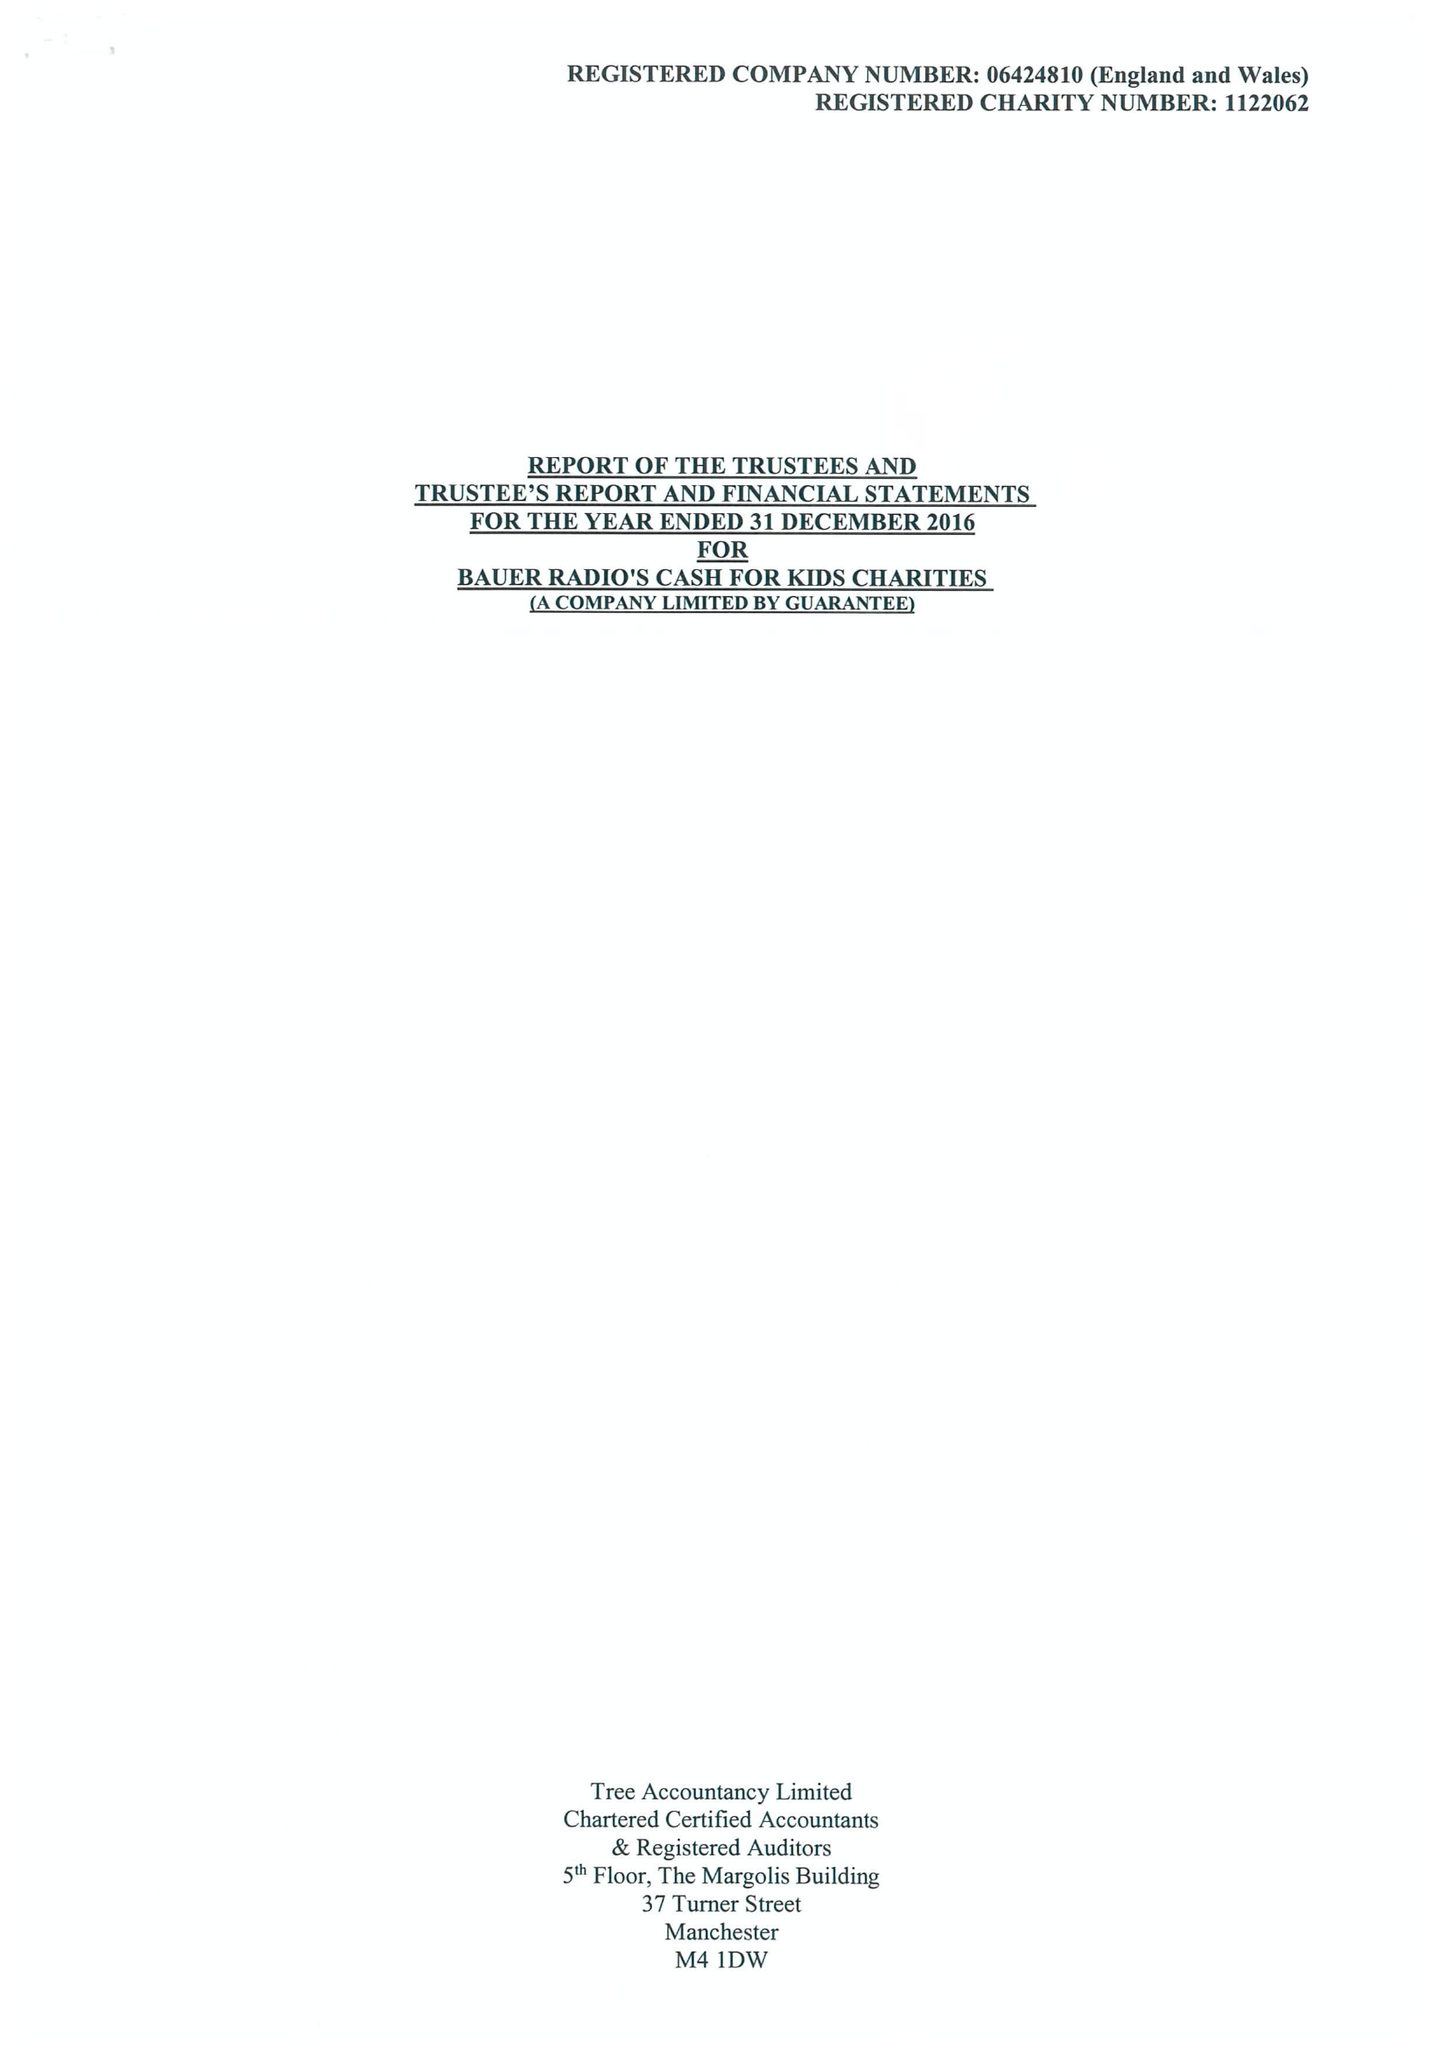What is the value for the report_date?
Answer the question using a single word or phrase. 2016-12-31 